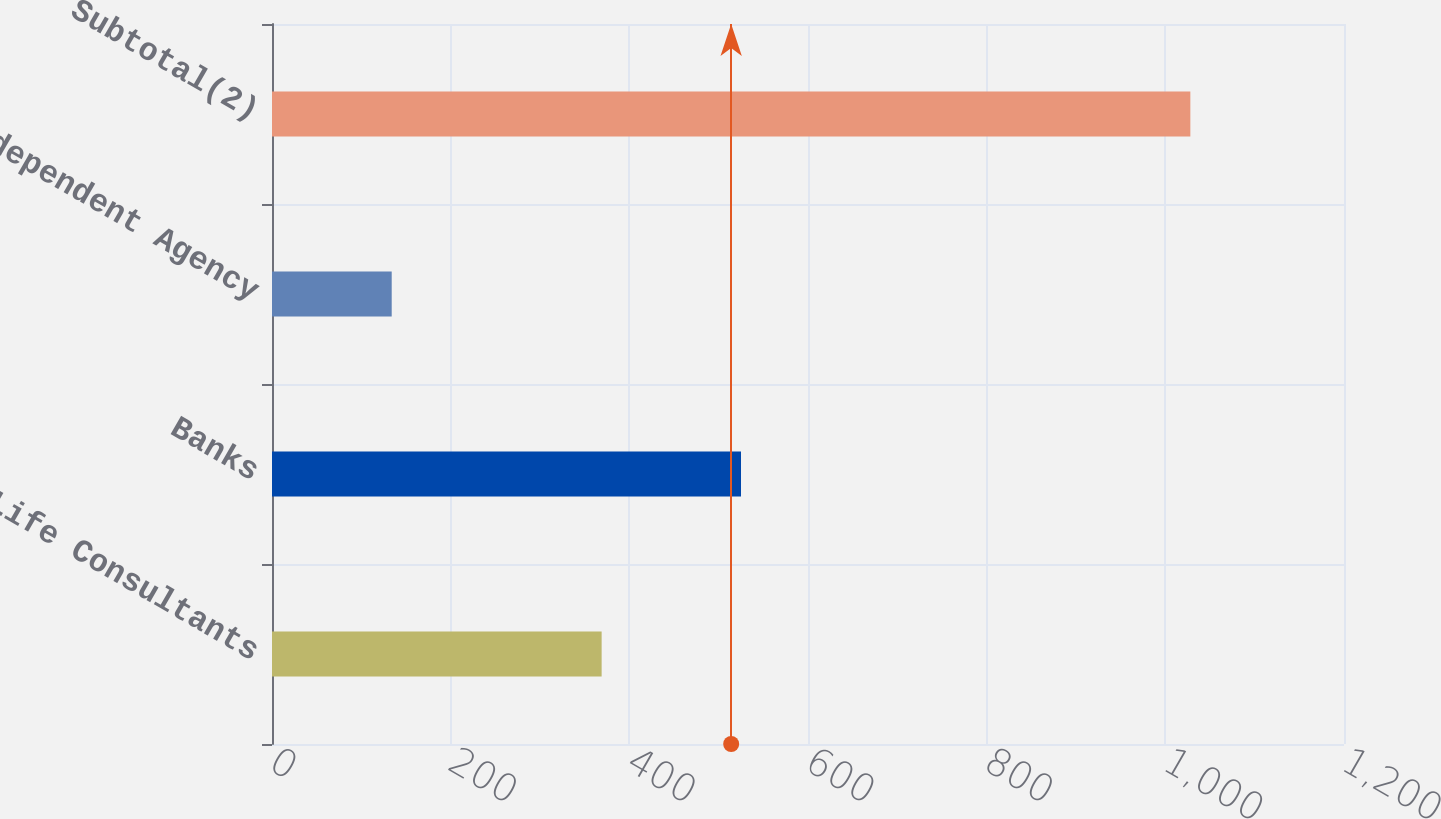<chart> <loc_0><loc_0><loc_500><loc_500><bar_chart><fcel>Life Consultants<fcel>Banks<fcel>Independent Agency<fcel>Subtotal(2)<nl><fcel>369<fcel>525<fcel>134<fcel>1028<nl></chart> 